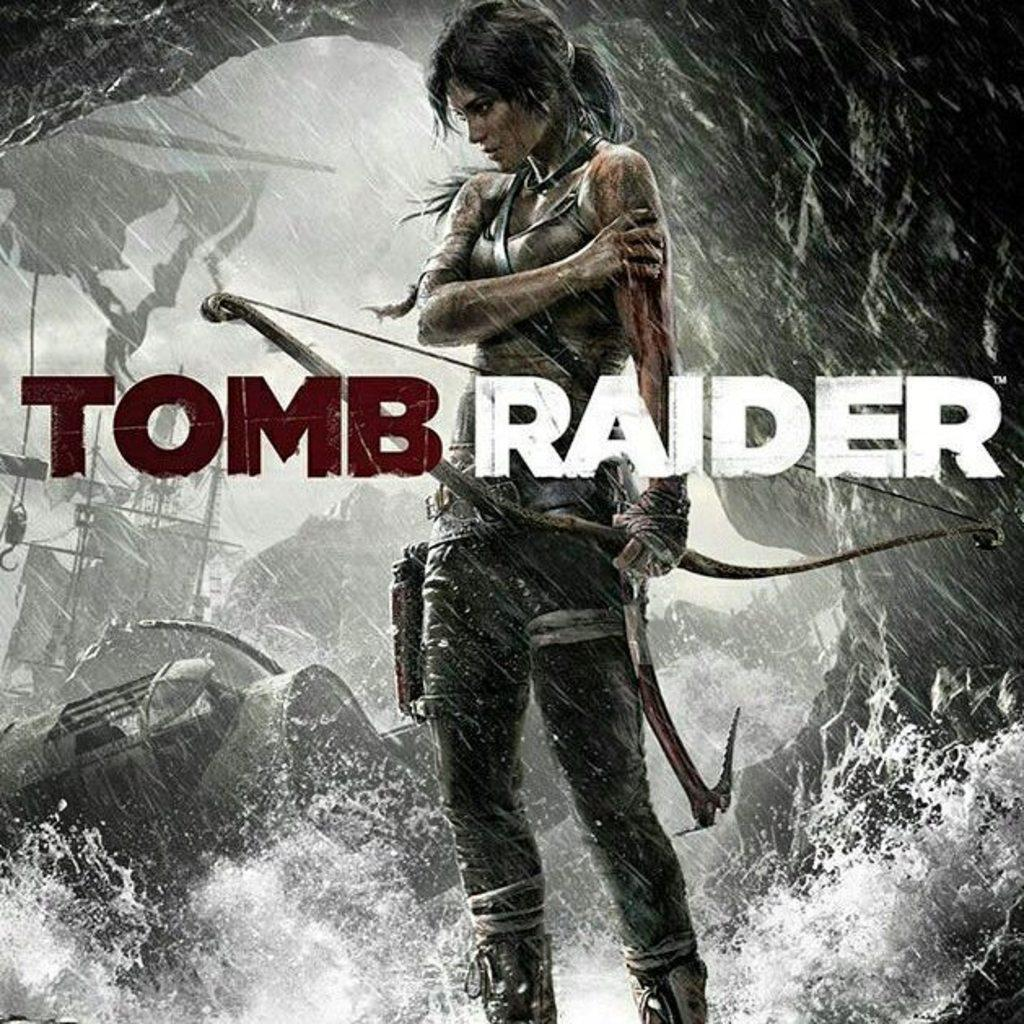What is depicted on the poster in the image? The poster features a woman standing in water. What words are written on the poster? The words "tomb raider" are written on the poster. What can be seen in the background of the image? There are vehicles and other objects in the background of the image. What type of skin condition does the woman on the poster have? There is no indication of a skin condition on the woman in the poster; she is simply standing in water. How does the poster change when you turn it around? The poster does not change when you turn it around, as the image provided is a static representation of the poster. 